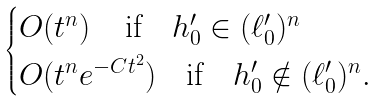<formula> <loc_0><loc_0><loc_500><loc_500>\begin{cases} O ( t ^ { n } ) \quad \, \text {if} \quad h ^ { \prime } _ { 0 } \in ( \ell _ { 0 } ^ { \prime } ) ^ { n } \\ O ( t ^ { n } e ^ { - C t ^ { 2 } } ) \quad \text {if} \quad h ^ { \prime } _ { 0 } \notin ( \ell _ { 0 } ^ { \prime } ) ^ { n } . \end{cases}</formula> 